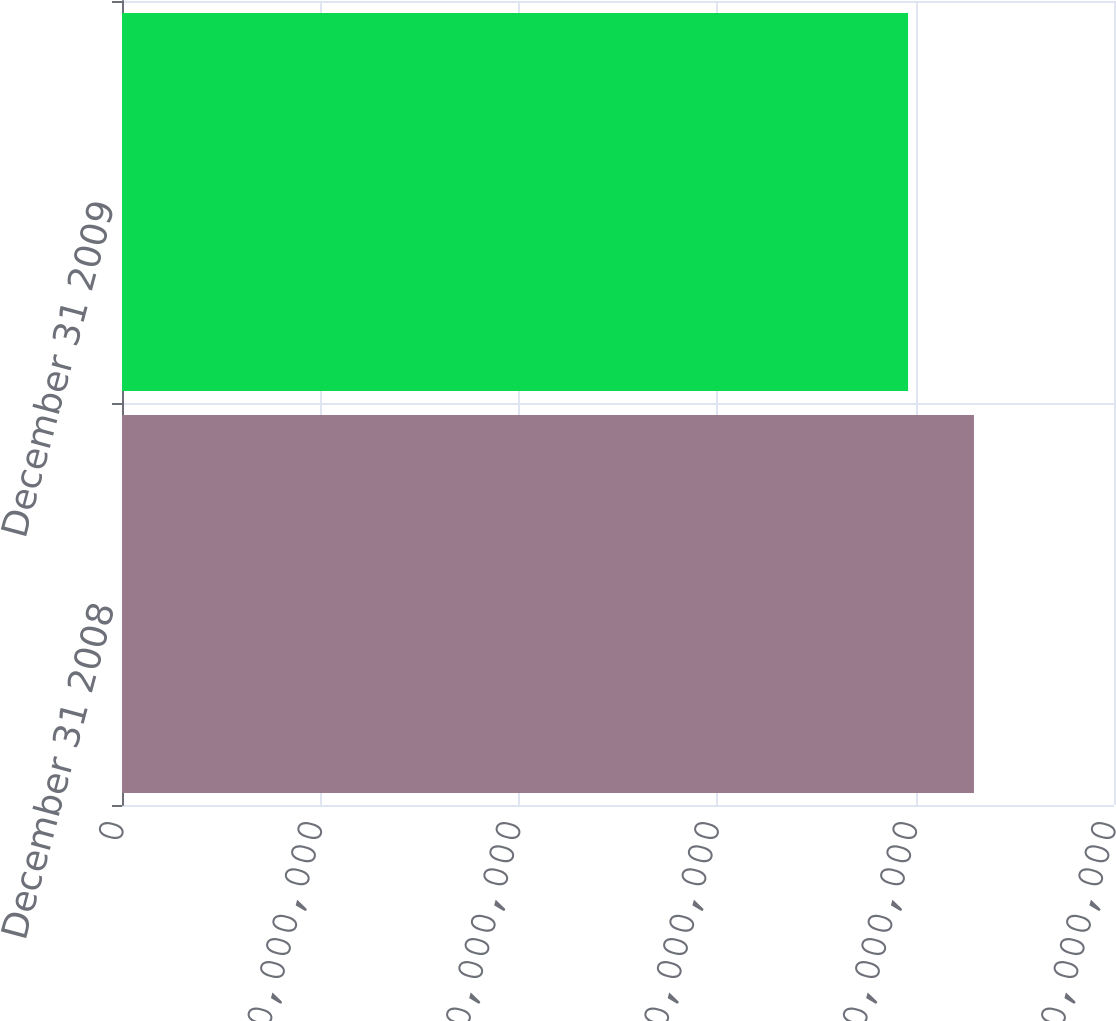Convert chart. <chart><loc_0><loc_0><loc_500><loc_500><bar_chart><fcel>December 31 2008<fcel>December 31 2009<nl><fcel>1.28827e+08<fcel>1.1886e+08<nl></chart> 